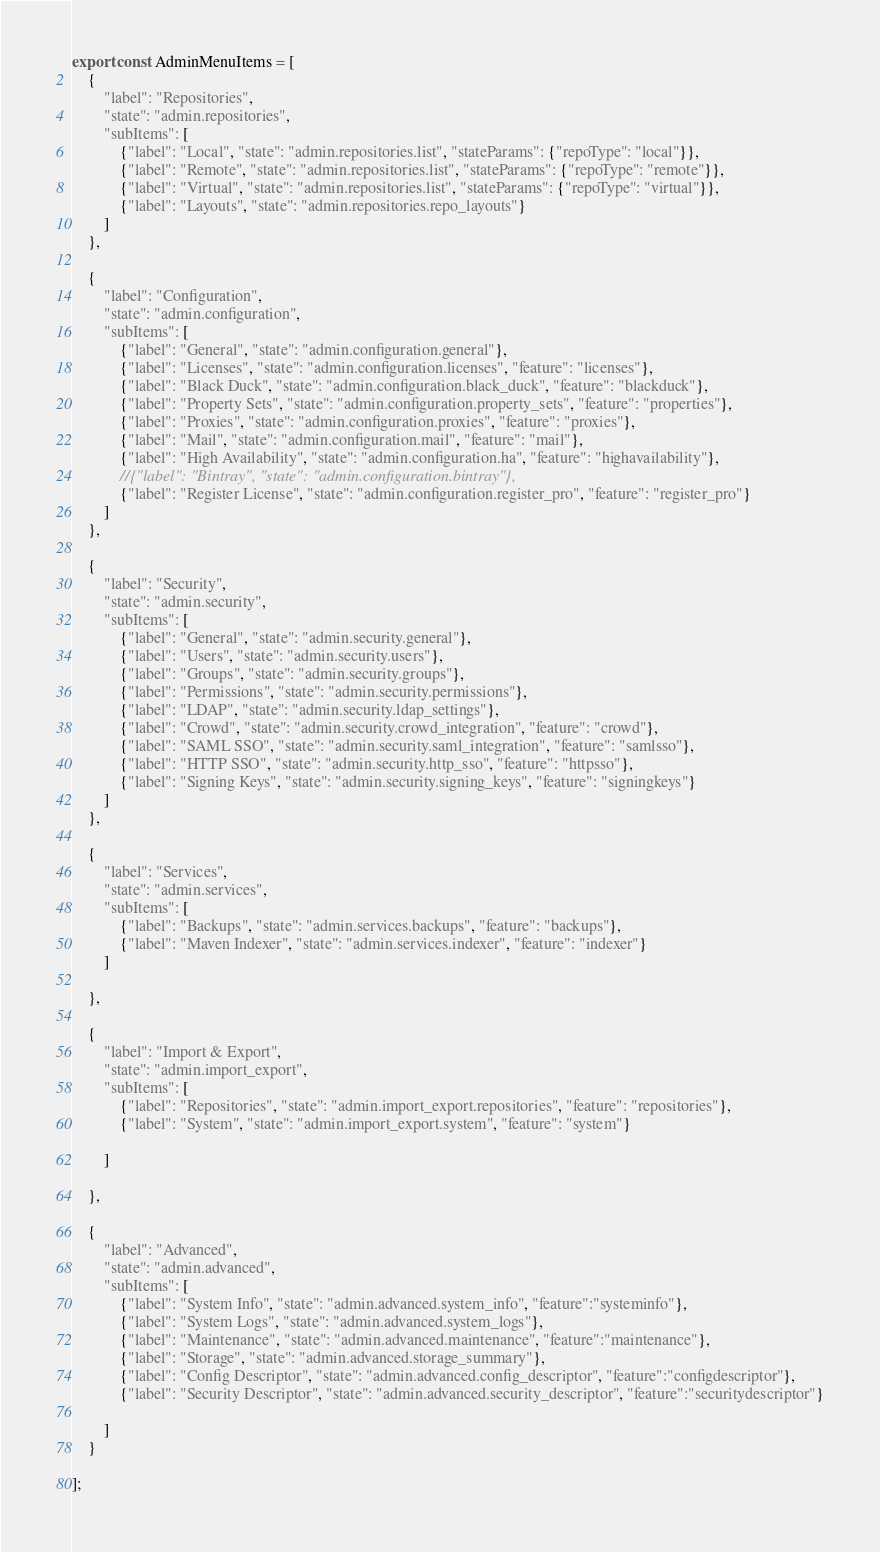Convert code to text. <code><loc_0><loc_0><loc_500><loc_500><_JavaScript_>export const AdminMenuItems = [
    {
        "label": "Repositories",
        "state": "admin.repositories",
        "subItems": [
            {"label": "Local", "state": "admin.repositories.list", "stateParams": {"repoType": "local"}},
            {"label": "Remote", "state": "admin.repositories.list", "stateParams": {"repoType": "remote"}},
            {"label": "Virtual", "state": "admin.repositories.list", "stateParams": {"repoType": "virtual"}},
            {"label": "Layouts", "state": "admin.repositories.repo_layouts"}
        ]
    },

    {
        "label": "Configuration",
        "state": "admin.configuration",
        "subItems": [
            {"label": "General", "state": "admin.configuration.general"},
            {"label": "Licenses", "state": "admin.configuration.licenses", "feature": "licenses"},
            {"label": "Black Duck", "state": "admin.configuration.black_duck", "feature": "blackduck"},
            {"label": "Property Sets", "state": "admin.configuration.property_sets", "feature": "properties"},
            {"label": "Proxies", "state": "admin.configuration.proxies", "feature": "proxies"},
            {"label": "Mail", "state": "admin.configuration.mail", "feature": "mail"},
            {"label": "High Availability", "state": "admin.configuration.ha", "feature": "highavailability"},
            //{"label": "Bintray", "state": "admin.configuration.bintray"},
            {"label": "Register License", "state": "admin.configuration.register_pro", "feature": "register_pro"}
        ]
    },

    {
        "label": "Security",
        "state": "admin.security",
        "subItems": [
            {"label": "General", "state": "admin.security.general"},
            {"label": "Users", "state": "admin.security.users"},
            {"label": "Groups", "state": "admin.security.groups"},
            {"label": "Permissions", "state": "admin.security.permissions"},
            {"label": "LDAP", "state": "admin.security.ldap_settings"},
            {"label": "Crowd", "state": "admin.security.crowd_integration", "feature": "crowd"},
            {"label": "SAML SSO", "state": "admin.security.saml_integration", "feature": "samlsso"},
            {"label": "HTTP SSO", "state": "admin.security.http_sso", "feature": "httpsso"},
            {"label": "Signing Keys", "state": "admin.security.signing_keys", "feature": "signingkeys"}
        ]
    },

    {
        "label": "Services",
        "state": "admin.services",
        "subItems": [
            {"label": "Backups", "state": "admin.services.backups", "feature": "backups"},
            {"label": "Maven Indexer", "state": "admin.services.indexer", "feature": "indexer"}
        ]

    },

    {
        "label": "Import & Export",
        "state": "admin.import_export",
        "subItems": [
            {"label": "Repositories", "state": "admin.import_export.repositories", "feature": "repositories"},
            {"label": "System", "state": "admin.import_export.system", "feature": "system"}

        ]

    },

    {
        "label": "Advanced",
        "state": "admin.advanced",
        "subItems": [
            {"label": "System Info", "state": "admin.advanced.system_info", "feature":"systeminfo"},
            {"label": "System Logs", "state": "admin.advanced.system_logs"},
            {"label": "Maintenance", "state": "admin.advanced.maintenance", "feature":"maintenance"},
            {"label": "Storage", "state": "admin.advanced.storage_summary"},
            {"label": "Config Descriptor", "state": "admin.advanced.config_descriptor", "feature":"configdescriptor"},
            {"label": "Security Descriptor", "state": "admin.advanced.security_descriptor", "feature":"securitydescriptor"}

        ]
    }

];</code> 